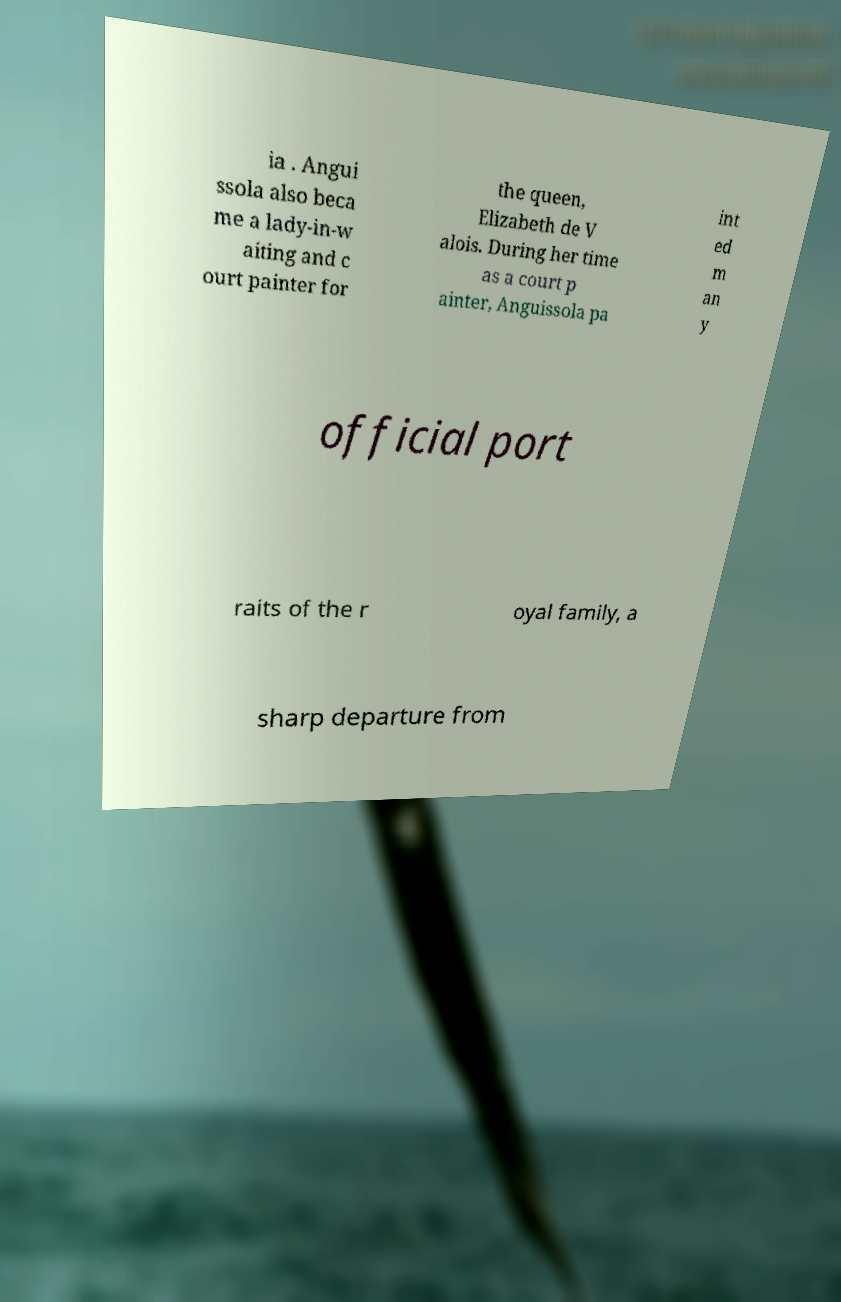Could you extract and type out the text from this image? ia . Angui ssola also beca me a lady-in-w aiting and c ourt painter for the queen, Elizabeth de V alois. During her time as a court p ainter, Anguissola pa int ed m an y official port raits of the r oyal family, a sharp departure from 